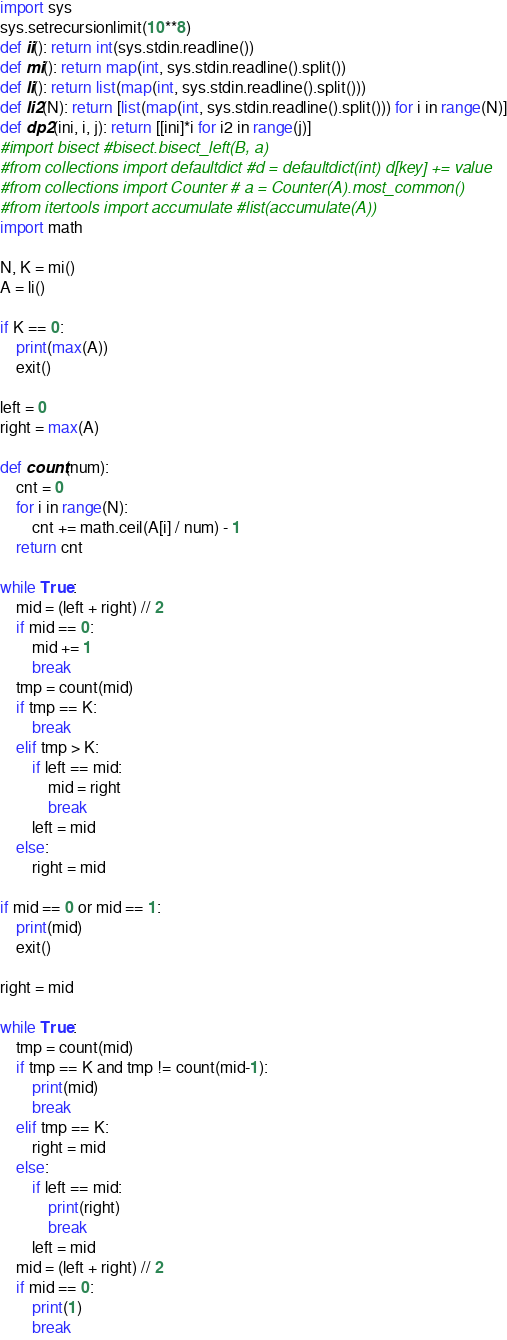Convert code to text. <code><loc_0><loc_0><loc_500><loc_500><_Python_>import sys
sys.setrecursionlimit(10**8)
def ii(): return int(sys.stdin.readline())
def mi(): return map(int, sys.stdin.readline().split())
def li(): return list(map(int, sys.stdin.readline().split()))
def li2(N): return [list(map(int, sys.stdin.readline().split())) for i in range(N)]
def dp2(ini, i, j): return [[ini]*i for i2 in range(j)]
#import bisect #bisect.bisect_left(B, a)
#from collections import defaultdict #d = defaultdict(int) d[key] += value
#from collections import Counter # a = Counter(A).most_common()
#from itertools import accumulate #list(accumulate(A))
import math
 
N, K = mi()
A = li()
 
if K == 0:
    print(max(A))
    exit()
 
left = 0
right = max(A)
 
def count(num):
    cnt = 0
    for i in range(N):
        cnt += math.ceil(A[i] / num) - 1
    return cnt
 
while True:
    mid = (left + right) // 2
    if mid == 0:
        mid += 1
        break
    tmp = count(mid)
    if tmp == K:
        break
    elif tmp > K:
        if left == mid:
            mid = right
            break
        left = mid
    else:
        right = mid
 
if mid == 0 or mid == 1:
    print(mid)
    exit()
 
right = mid
 
while True:
    tmp = count(mid)
    if tmp == K and tmp != count(mid-1):
        print(mid)
        break
    elif tmp == K:
        right = mid
    else:
        if left == mid:
            print(right)
            break
        left = mid
    mid = (left + right) // 2
    if mid == 0:
        print(1)
        break</code> 